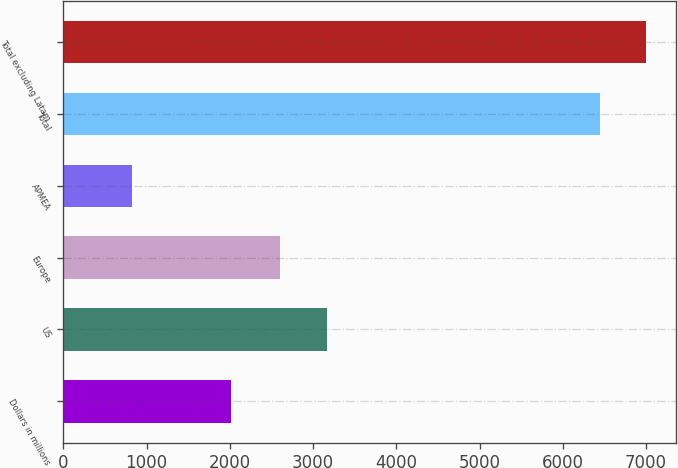Convert chart. <chart><loc_0><loc_0><loc_500><loc_500><bar_chart><fcel>Dollars in millions<fcel>US<fcel>Europe<fcel>APMEA<fcel>Total<fcel>Total excluding Latam<nl><fcel>2008<fcel>3170.4<fcel>2608<fcel>819<fcel>6443<fcel>7005.4<nl></chart> 